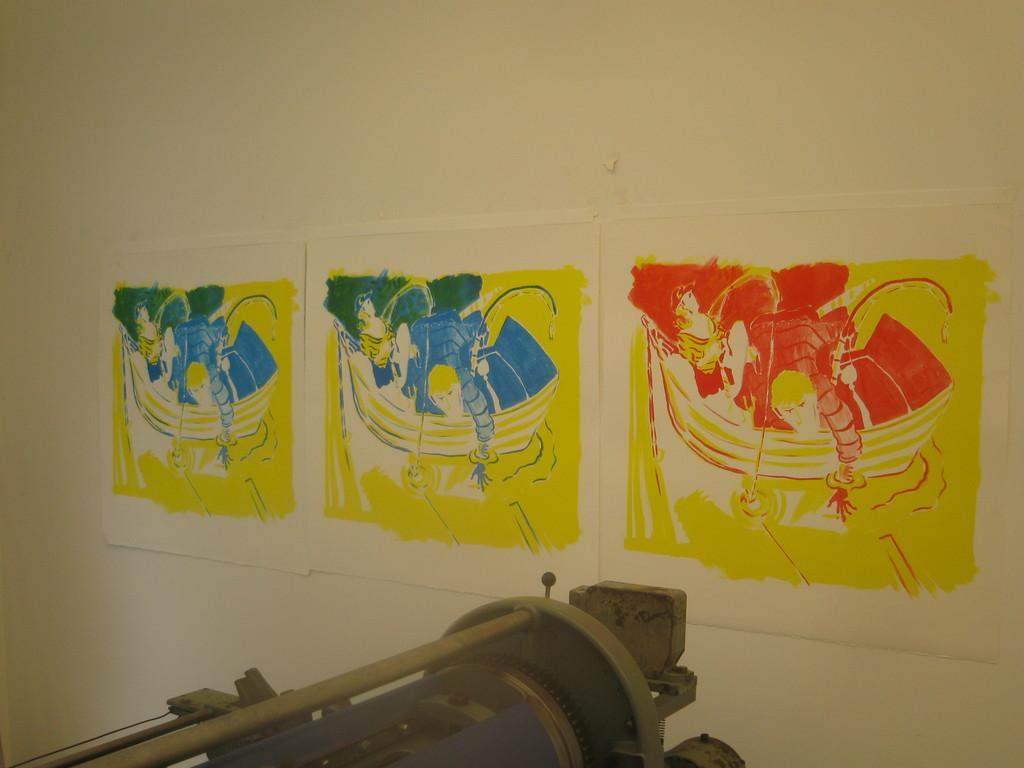What type of artwork is visible in the image? There are paintings on paper in the image. Where are the paintings located? The paper with paintings is attached to a wall. What other object can be seen in the image? There is a machine in the image. How many fingers can be seen touching the paintings in the image? There are no fingers visible in the image, as it only shows paintings on paper, a wall, and a machine. 